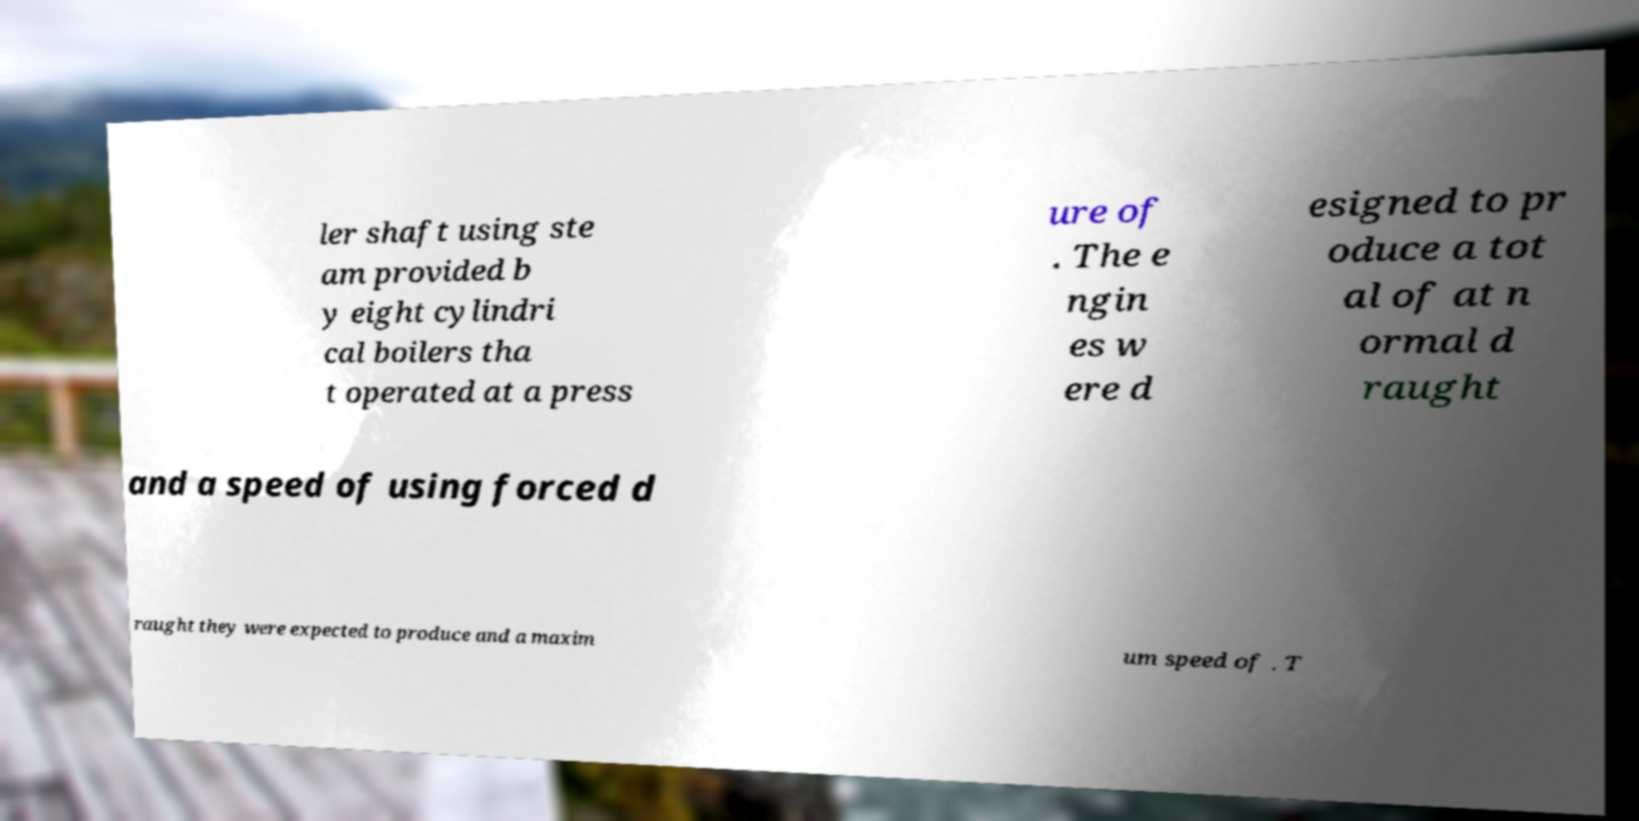Please read and relay the text visible in this image. What does it say? ler shaft using ste am provided b y eight cylindri cal boilers tha t operated at a press ure of . The e ngin es w ere d esigned to pr oduce a tot al of at n ormal d raught and a speed of using forced d raught they were expected to produce and a maxim um speed of . T 